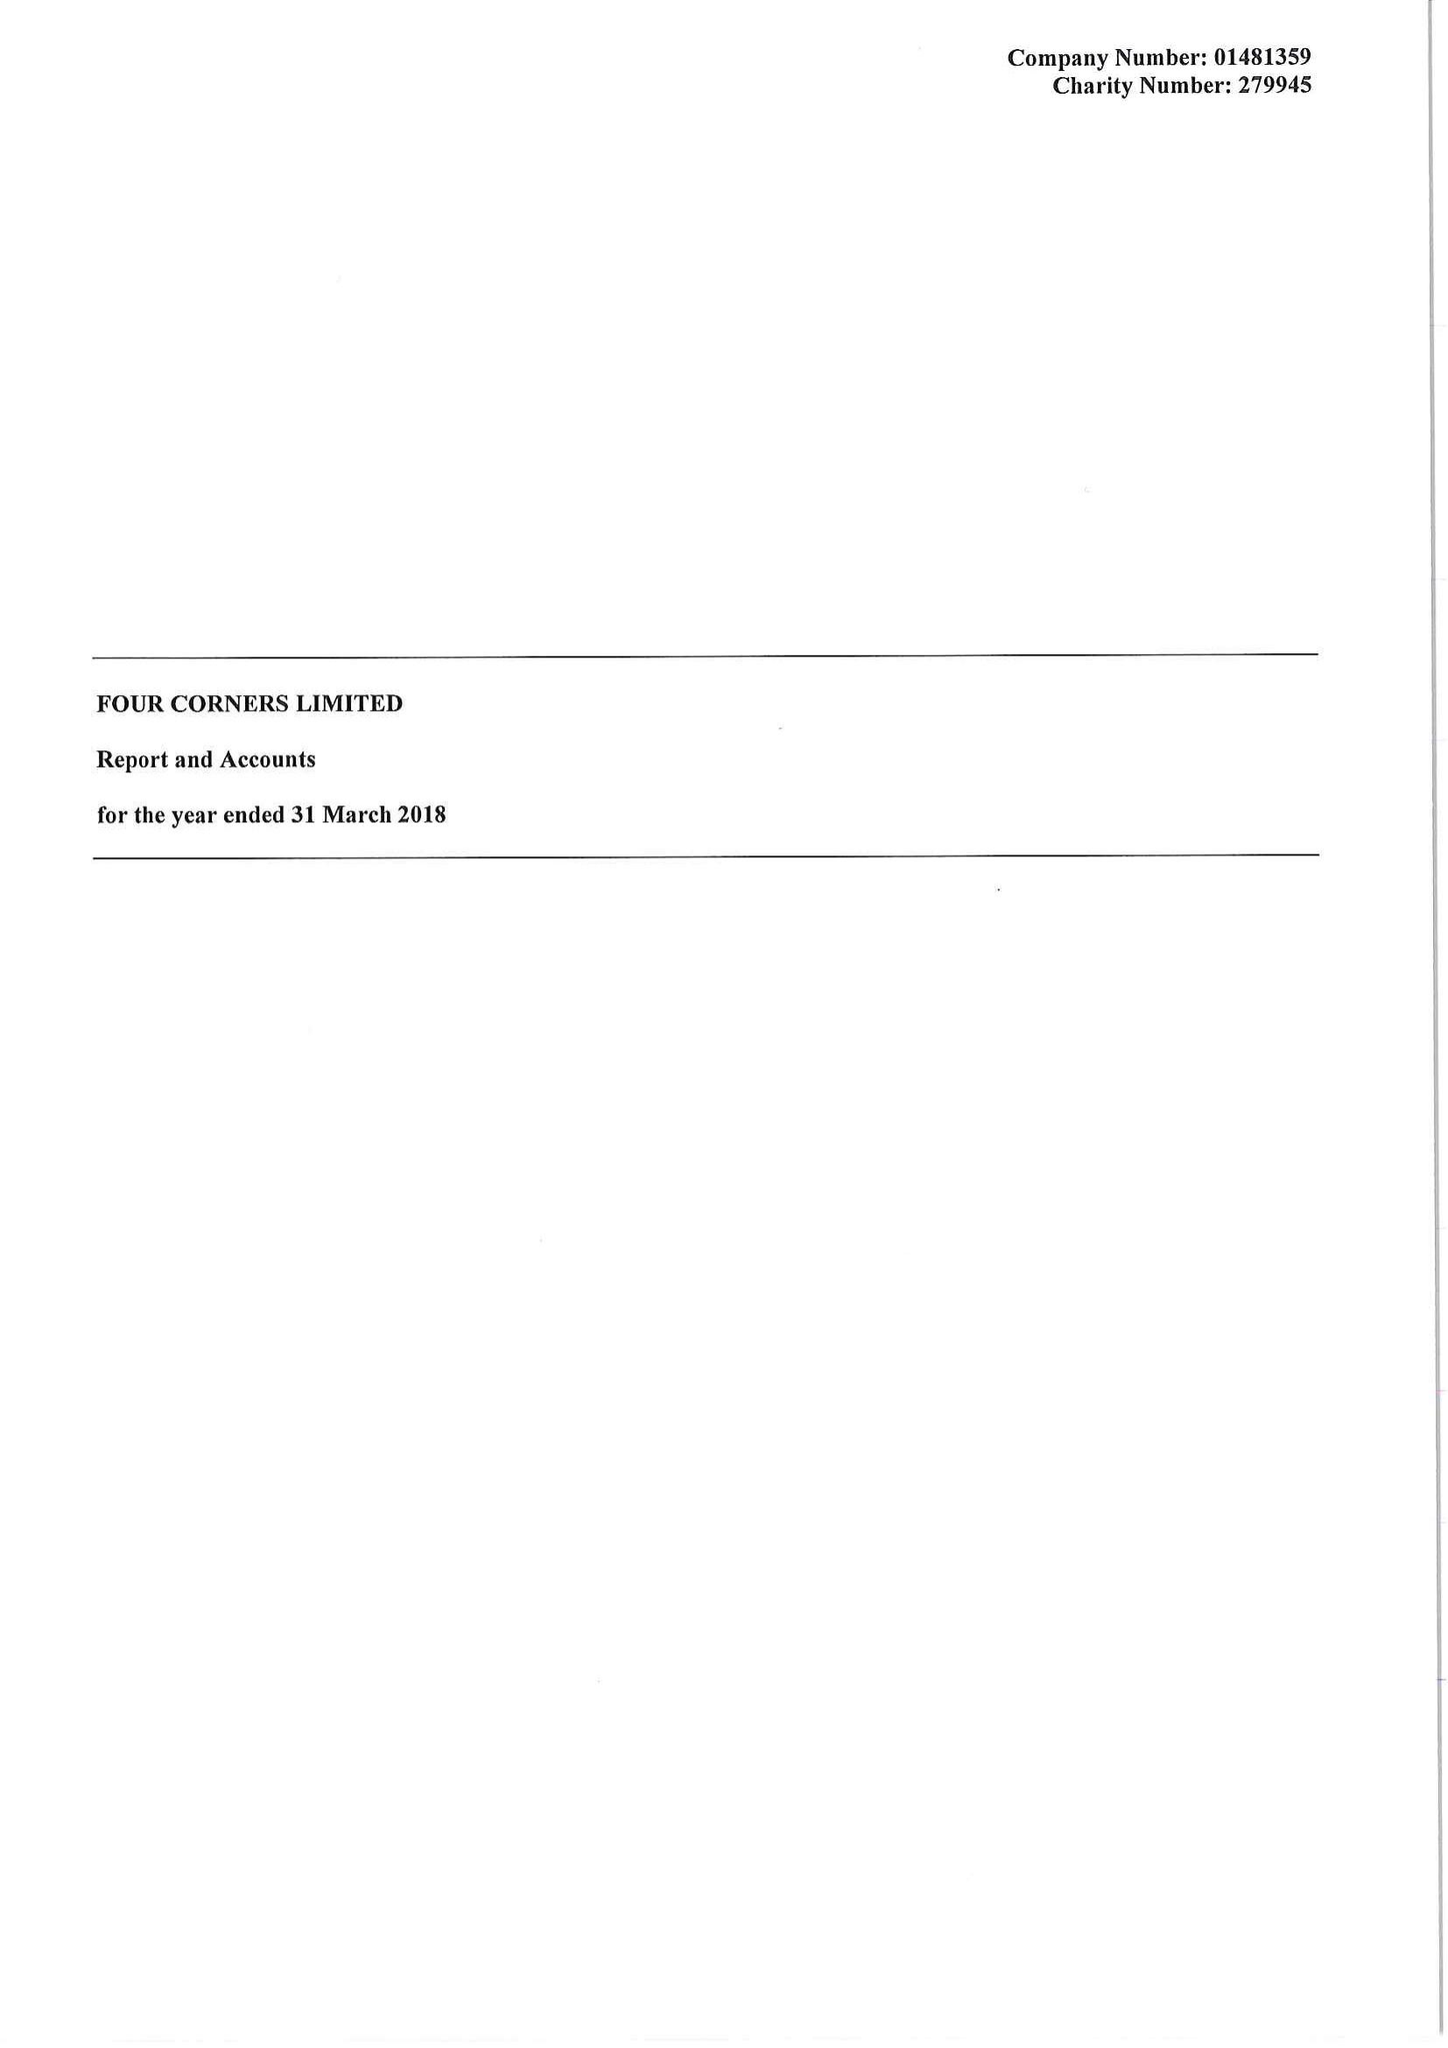What is the value for the income_annually_in_british_pounds?
Answer the question using a single word or phrase. 450108.00 